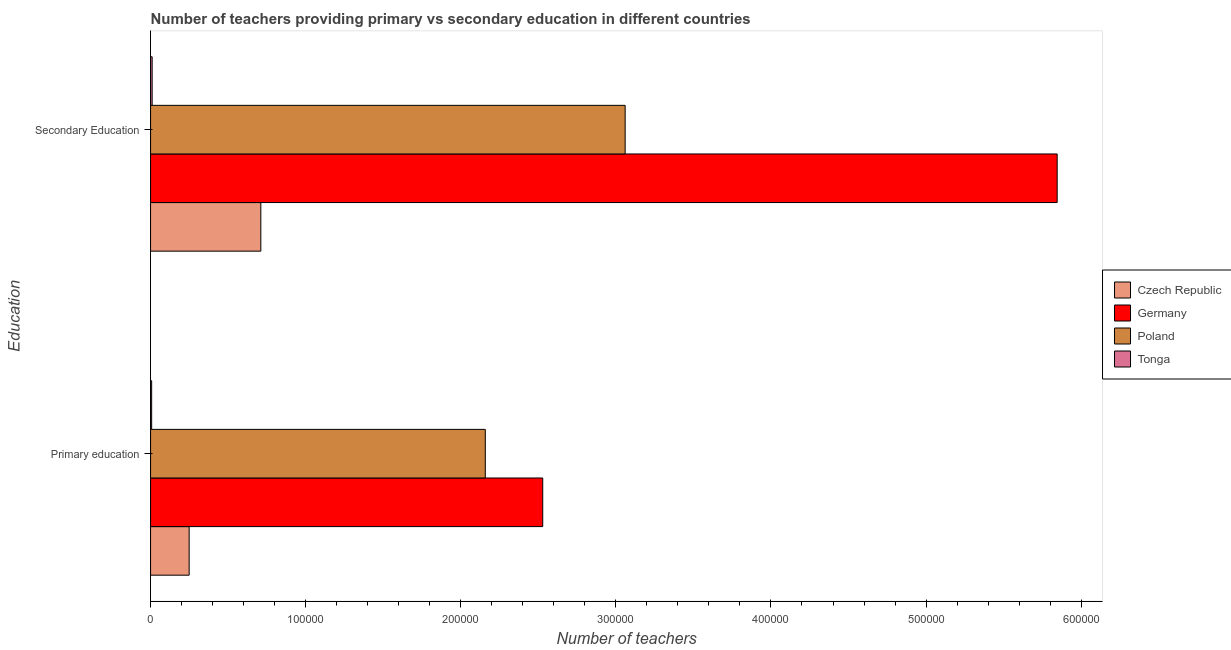What is the label of the 2nd group of bars from the top?
Offer a terse response. Primary education. What is the number of secondary teachers in Germany?
Your response must be concise. 5.85e+05. Across all countries, what is the maximum number of secondary teachers?
Your answer should be very brief. 5.85e+05. Across all countries, what is the minimum number of secondary teachers?
Provide a short and direct response. 1021. In which country was the number of primary teachers maximum?
Ensure brevity in your answer.  Germany. In which country was the number of secondary teachers minimum?
Make the answer very short. Tonga. What is the total number of primary teachers in the graph?
Your answer should be compact. 4.94e+05. What is the difference between the number of primary teachers in Germany and that in Poland?
Your answer should be compact. 3.70e+04. What is the difference between the number of primary teachers in Tonga and the number of secondary teachers in Germany?
Your response must be concise. -5.84e+05. What is the average number of secondary teachers per country?
Offer a very short reply. 2.41e+05. What is the difference between the number of primary teachers and number of secondary teachers in Germany?
Your answer should be compact. -3.32e+05. What is the ratio of the number of primary teachers in Poland to that in Germany?
Offer a very short reply. 0.85. What does the 1st bar from the bottom in Primary education represents?
Your response must be concise. Czech Republic. How many bars are there?
Give a very brief answer. 8. Are all the bars in the graph horizontal?
Ensure brevity in your answer.  Yes. How many countries are there in the graph?
Ensure brevity in your answer.  4. What is the title of the graph?
Give a very brief answer. Number of teachers providing primary vs secondary education in different countries. What is the label or title of the X-axis?
Offer a very short reply. Number of teachers. What is the label or title of the Y-axis?
Ensure brevity in your answer.  Education. What is the Number of teachers of Czech Republic in Primary education?
Ensure brevity in your answer.  2.49e+04. What is the Number of teachers of Germany in Primary education?
Provide a short and direct response. 2.53e+05. What is the Number of teachers of Poland in Primary education?
Make the answer very short. 2.16e+05. What is the Number of teachers in Tonga in Primary education?
Make the answer very short. 706. What is the Number of teachers of Czech Republic in Secondary Education?
Give a very brief answer. 7.11e+04. What is the Number of teachers of Germany in Secondary Education?
Your answer should be compact. 5.85e+05. What is the Number of teachers of Poland in Secondary Education?
Offer a very short reply. 3.06e+05. What is the Number of teachers in Tonga in Secondary Education?
Your response must be concise. 1021. Across all Education, what is the maximum Number of teachers in Czech Republic?
Ensure brevity in your answer.  7.11e+04. Across all Education, what is the maximum Number of teachers in Germany?
Your answer should be very brief. 5.85e+05. Across all Education, what is the maximum Number of teachers of Poland?
Provide a succinct answer. 3.06e+05. Across all Education, what is the maximum Number of teachers in Tonga?
Offer a very short reply. 1021. Across all Education, what is the minimum Number of teachers in Czech Republic?
Give a very brief answer. 2.49e+04. Across all Education, what is the minimum Number of teachers in Germany?
Your answer should be compact. 2.53e+05. Across all Education, what is the minimum Number of teachers of Poland?
Make the answer very short. 2.16e+05. Across all Education, what is the minimum Number of teachers of Tonga?
Give a very brief answer. 706. What is the total Number of teachers of Czech Republic in the graph?
Keep it short and to the point. 9.60e+04. What is the total Number of teachers in Germany in the graph?
Keep it short and to the point. 8.37e+05. What is the total Number of teachers in Poland in the graph?
Provide a succinct answer. 5.22e+05. What is the total Number of teachers of Tonga in the graph?
Offer a terse response. 1727. What is the difference between the Number of teachers of Czech Republic in Primary education and that in Secondary Education?
Your response must be concise. -4.62e+04. What is the difference between the Number of teachers in Germany in Primary education and that in Secondary Education?
Your answer should be very brief. -3.32e+05. What is the difference between the Number of teachers in Poland in Primary education and that in Secondary Education?
Give a very brief answer. -9.02e+04. What is the difference between the Number of teachers in Tonga in Primary education and that in Secondary Education?
Offer a terse response. -315. What is the difference between the Number of teachers of Czech Republic in Primary education and the Number of teachers of Germany in Secondary Education?
Give a very brief answer. -5.60e+05. What is the difference between the Number of teachers in Czech Republic in Primary education and the Number of teachers in Poland in Secondary Education?
Make the answer very short. -2.81e+05. What is the difference between the Number of teachers in Czech Republic in Primary education and the Number of teachers in Tonga in Secondary Education?
Provide a short and direct response. 2.39e+04. What is the difference between the Number of teachers in Germany in Primary education and the Number of teachers in Poland in Secondary Education?
Offer a very short reply. -5.31e+04. What is the difference between the Number of teachers of Germany in Primary education and the Number of teachers of Tonga in Secondary Education?
Ensure brevity in your answer.  2.52e+05. What is the difference between the Number of teachers of Poland in Primary education and the Number of teachers of Tonga in Secondary Education?
Your answer should be compact. 2.15e+05. What is the average Number of teachers of Czech Republic per Education?
Provide a short and direct response. 4.80e+04. What is the average Number of teachers of Germany per Education?
Offer a terse response. 4.19e+05. What is the average Number of teachers of Poland per Education?
Offer a terse response. 2.61e+05. What is the average Number of teachers in Tonga per Education?
Your answer should be very brief. 863.5. What is the difference between the Number of teachers of Czech Republic and Number of teachers of Germany in Primary education?
Your answer should be compact. -2.28e+05. What is the difference between the Number of teachers of Czech Republic and Number of teachers of Poland in Primary education?
Make the answer very short. -1.91e+05. What is the difference between the Number of teachers in Czech Republic and Number of teachers in Tonga in Primary education?
Ensure brevity in your answer.  2.42e+04. What is the difference between the Number of teachers in Germany and Number of teachers in Poland in Primary education?
Provide a short and direct response. 3.70e+04. What is the difference between the Number of teachers of Germany and Number of teachers of Tonga in Primary education?
Keep it short and to the point. 2.52e+05. What is the difference between the Number of teachers in Poland and Number of teachers in Tonga in Primary education?
Provide a short and direct response. 2.15e+05. What is the difference between the Number of teachers in Czech Republic and Number of teachers in Germany in Secondary Education?
Give a very brief answer. -5.13e+05. What is the difference between the Number of teachers of Czech Republic and Number of teachers of Poland in Secondary Education?
Provide a succinct answer. -2.35e+05. What is the difference between the Number of teachers of Czech Republic and Number of teachers of Tonga in Secondary Education?
Provide a succinct answer. 7.01e+04. What is the difference between the Number of teachers in Germany and Number of teachers in Poland in Secondary Education?
Give a very brief answer. 2.79e+05. What is the difference between the Number of teachers in Germany and Number of teachers in Tonga in Secondary Education?
Provide a short and direct response. 5.84e+05. What is the difference between the Number of teachers of Poland and Number of teachers of Tonga in Secondary Education?
Your response must be concise. 3.05e+05. What is the ratio of the Number of teachers of Germany in Primary education to that in Secondary Education?
Your response must be concise. 0.43. What is the ratio of the Number of teachers in Poland in Primary education to that in Secondary Education?
Keep it short and to the point. 0.71. What is the ratio of the Number of teachers of Tonga in Primary education to that in Secondary Education?
Offer a terse response. 0.69. What is the difference between the highest and the second highest Number of teachers of Czech Republic?
Keep it short and to the point. 4.62e+04. What is the difference between the highest and the second highest Number of teachers of Germany?
Your answer should be compact. 3.32e+05. What is the difference between the highest and the second highest Number of teachers of Poland?
Your answer should be compact. 9.02e+04. What is the difference between the highest and the second highest Number of teachers of Tonga?
Your answer should be compact. 315. What is the difference between the highest and the lowest Number of teachers of Czech Republic?
Provide a short and direct response. 4.62e+04. What is the difference between the highest and the lowest Number of teachers in Germany?
Provide a short and direct response. 3.32e+05. What is the difference between the highest and the lowest Number of teachers of Poland?
Ensure brevity in your answer.  9.02e+04. What is the difference between the highest and the lowest Number of teachers of Tonga?
Give a very brief answer. 315. 